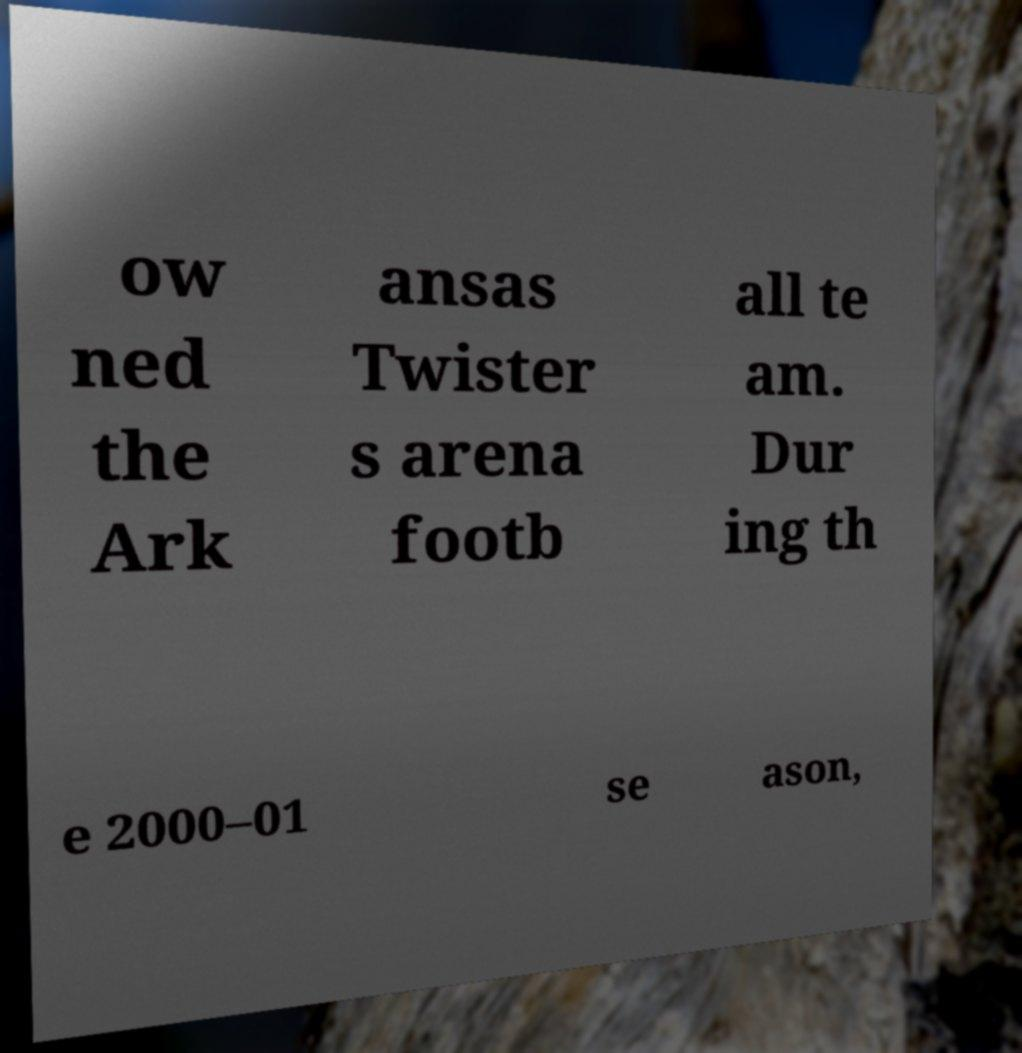Please identify and transcribe the text found in this image. ow ned the Ark ansas Twister s arena footb all te am. Dur ing th e 2000–01 se ason, 